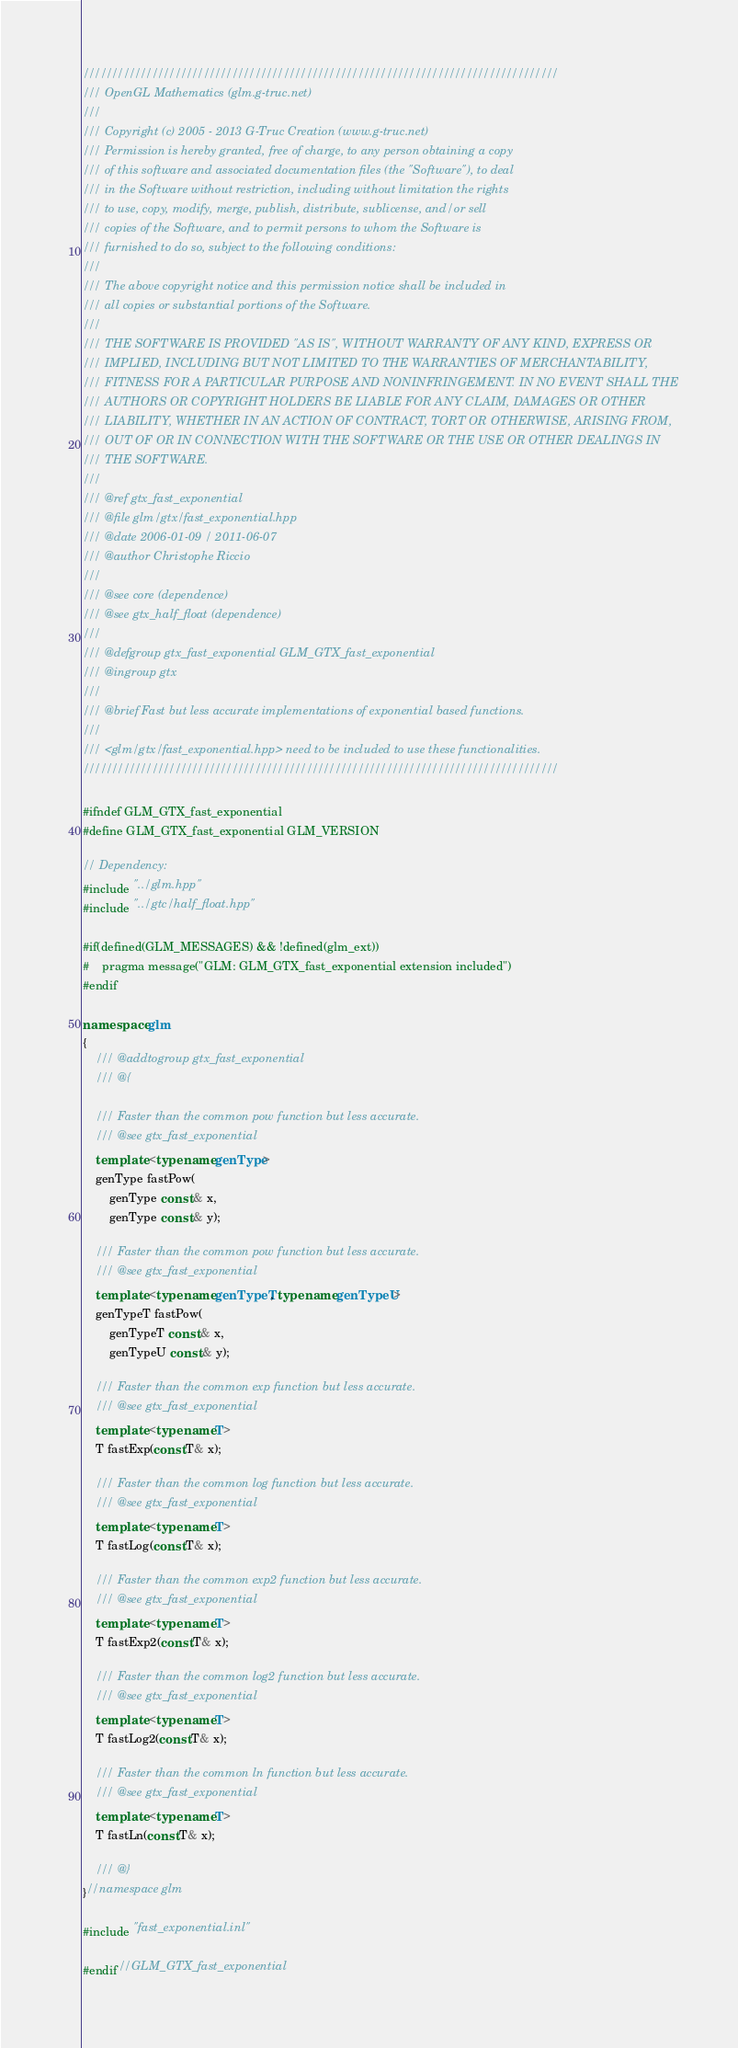Convert code to text. <code><loc_0><loc_0><loc_500><loc_500><_C++_>///////////////////////////////////////////////////////////////////////////////////
/// OpenGL Mathematics (glm.g-truc.net)
///
/// Copyright (c) 2005 - 2013 G-Truc Creation (www.g-truc.net)
/// Permission is hereby granted, free of charge, to any person obtaining a copy
/// of this software and associated documentation files (the "Software"), to deal
/// in the Software without restriction, including without limitation the rights
/// to use, copy, modify, merge, publish, distribute, sublicense, and/or sell
/// copies of the Software, and to permit persons to whom the Software is
/// furnished to do so, subject to the following conditions:
/// 
/// The above copyright notice and this permission notice shall be included in
/// all copies or substantial portions of the Software.
/// 
/// THE SOFTWARE IS PROVIDED "AS IS", WITHOUT WARRANTY OF ANY KIND, EXPRESS OR
/// IMPLIED, INCLUDING BUT NOT LIMITED TO THE WARRANTIES OF MERCHANTABILITY,
/// FITNESS FOR A PARTICULAR PURPOSE AND NONINFRINGEMENT. IN NO EVENT SHALL THE
/// AUTHORS OR COPYRIGHT HOLDERS BE LIABLE FOR ANY CLAIM, DAMAGES OR OTHER
/// LIABILITY, WHETHER IN AN ACTION OF CONTRACT, TORT OR OTHERWISE, ARISING FROM,
/// OUT OF OR IN CONNECTION WITH THE SOFTWARE OR THE USE OR OTHER DEALINGS IN
/// THE SOFTWARE.
///
/// @ref gtx_fast_exponential
/// @file glm/gtx/fast_exponential.hpp
/// @date 2006-01-09 / 2011-06-07
/// @author Christophe Riccio
///
/// @see core (dependence)
/// @see gtx_half_float (dependence)
///
/// @defgroup gtx_fast_exponential GLM_GTX_fast_exponential
/// @ingroup gtx
/// 
/// @brief Fast but less accurate implementations of exponential based functions.
/// 
/// <glm/gtx/fast_exponential.hpp> need to be included to use these functionalities.
///////////////////////////////////////////////////////////////////////////////////

#ifndef GLM_GTX_fast_exponential
#define GLM_GTX_fast_exponential GLM_VERSION

// Dependency:
#include "../glm.hpp"
#include "../gtc/half_float.hpp"

#if(defined(GLM_MESSAGES) && !defined(glm_ext))
#	pragma message("GLM: GLM_GTX_fast_exponential extension included")
#endif

namespace glm
{
	/// @addtogroup gtx_fast_exponential
	/// @{

	/// Faster than the common pow function but less accurate.
	/// @see gtx_fast_exponential
	template <typename genType> 
	genType fastPow(
		genType const & x, 
		genType const & y);

	/// Faster than the common pow function but less accurate.
	/// @see gtx_fast_exponential
	template <typename genTypeT, typename genTypeU> 
	genTypeT fastPow(
		genTypeT const & x, 
		genTypeU const & y);
		
	/// Faster than the common exp function but less accurate.
	/// @see gtx_fast_exponential
	template <typename T> 
	T fastExp(const T& x);
		
	/// Faster than the common log function but less accurate.
	/// @see gtx_fast_exponential
	template <typename T> 
	T fastLog(const T& x);

	/// Faster than the common exp2 function but less accurate.
	/// @see gtx_fast_exponential
	template <typename T> 
	T fastExp2(const T& x);
		
	/// Faster than the common log2 function but less accurate.
	/// @see gtx_fast_exponential
	template <typename T> 
	T fastLog2(const T& x);

	/// Faster than the common ln function but less accurate.
	/// @see gtx_fast_exponential
	template <typename T> 
	T fastLn(const T& x);

	/// @}
}//namespace glm

#include "fast_exponential.inl"

#endif//GLM_GTX_fast_exponential
</code> 